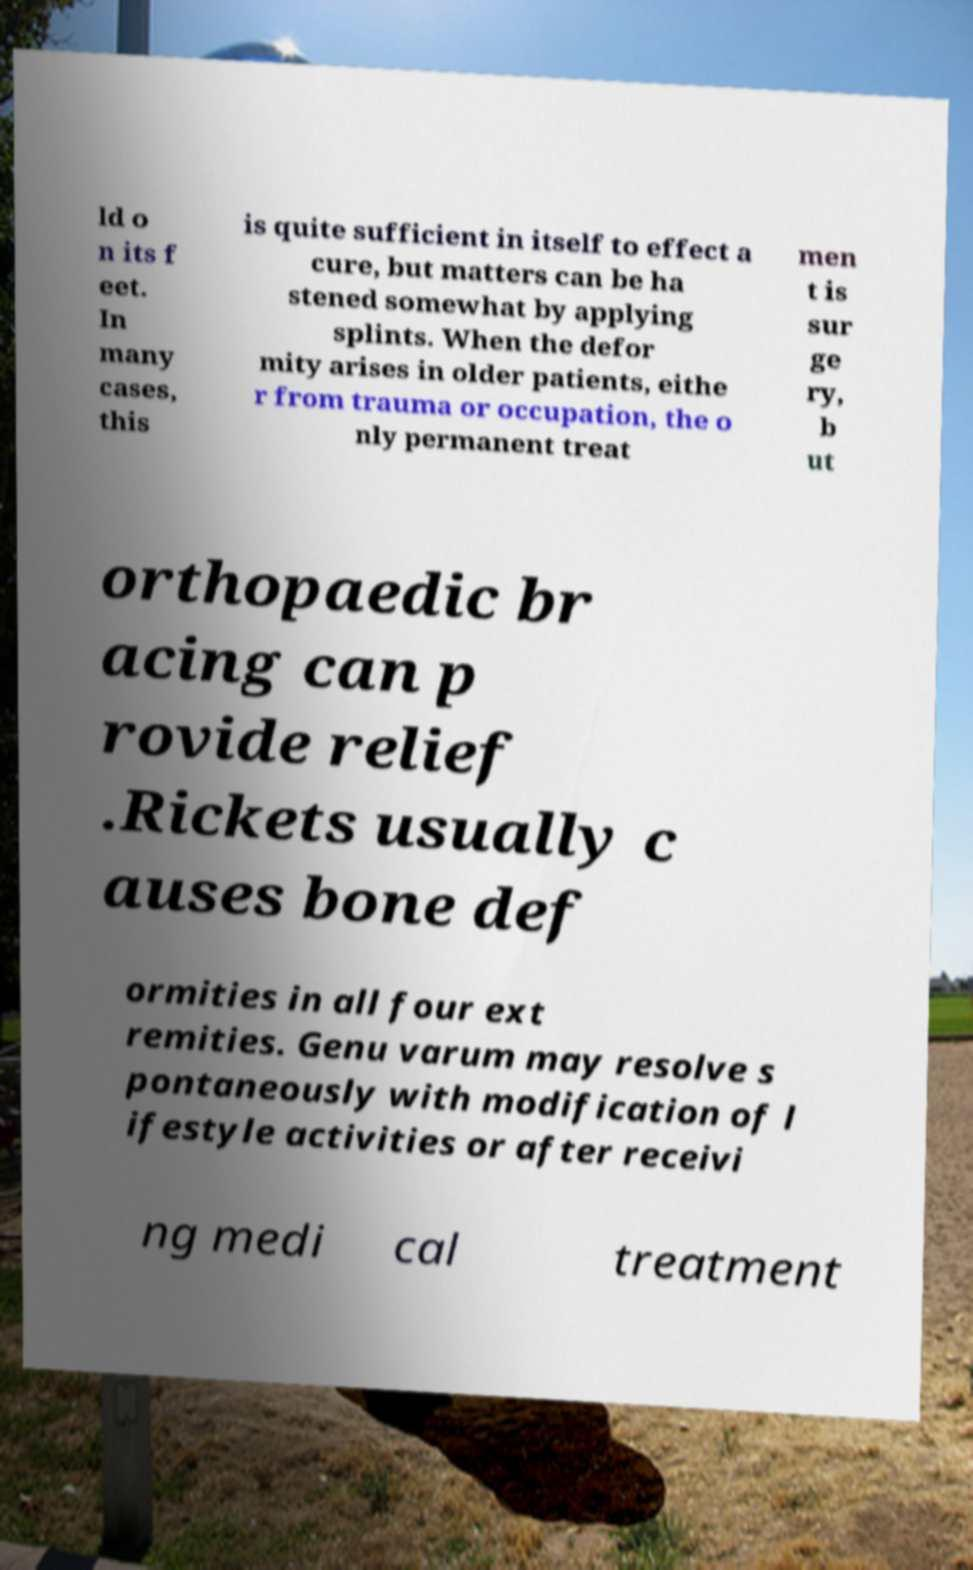Please read and relay the text visible in this image. What does it say? ld o n its f eet. In many cases, this is quite sufficient in itself to effect a cure, but matters can be ha stened somewhat by applying splints. When the defor mity arises in older patients, eithe r from trauma or occupation, the o nly permanent treat men t is sur ge ry, b ut orthopaedic br acing can p rovide relief .Rickets usually c auses bone def ormities in all four ext remities. Genu varum may resolve s pontaneously with modification of l ifestyle activities or after receivi ng medi cal treatment 